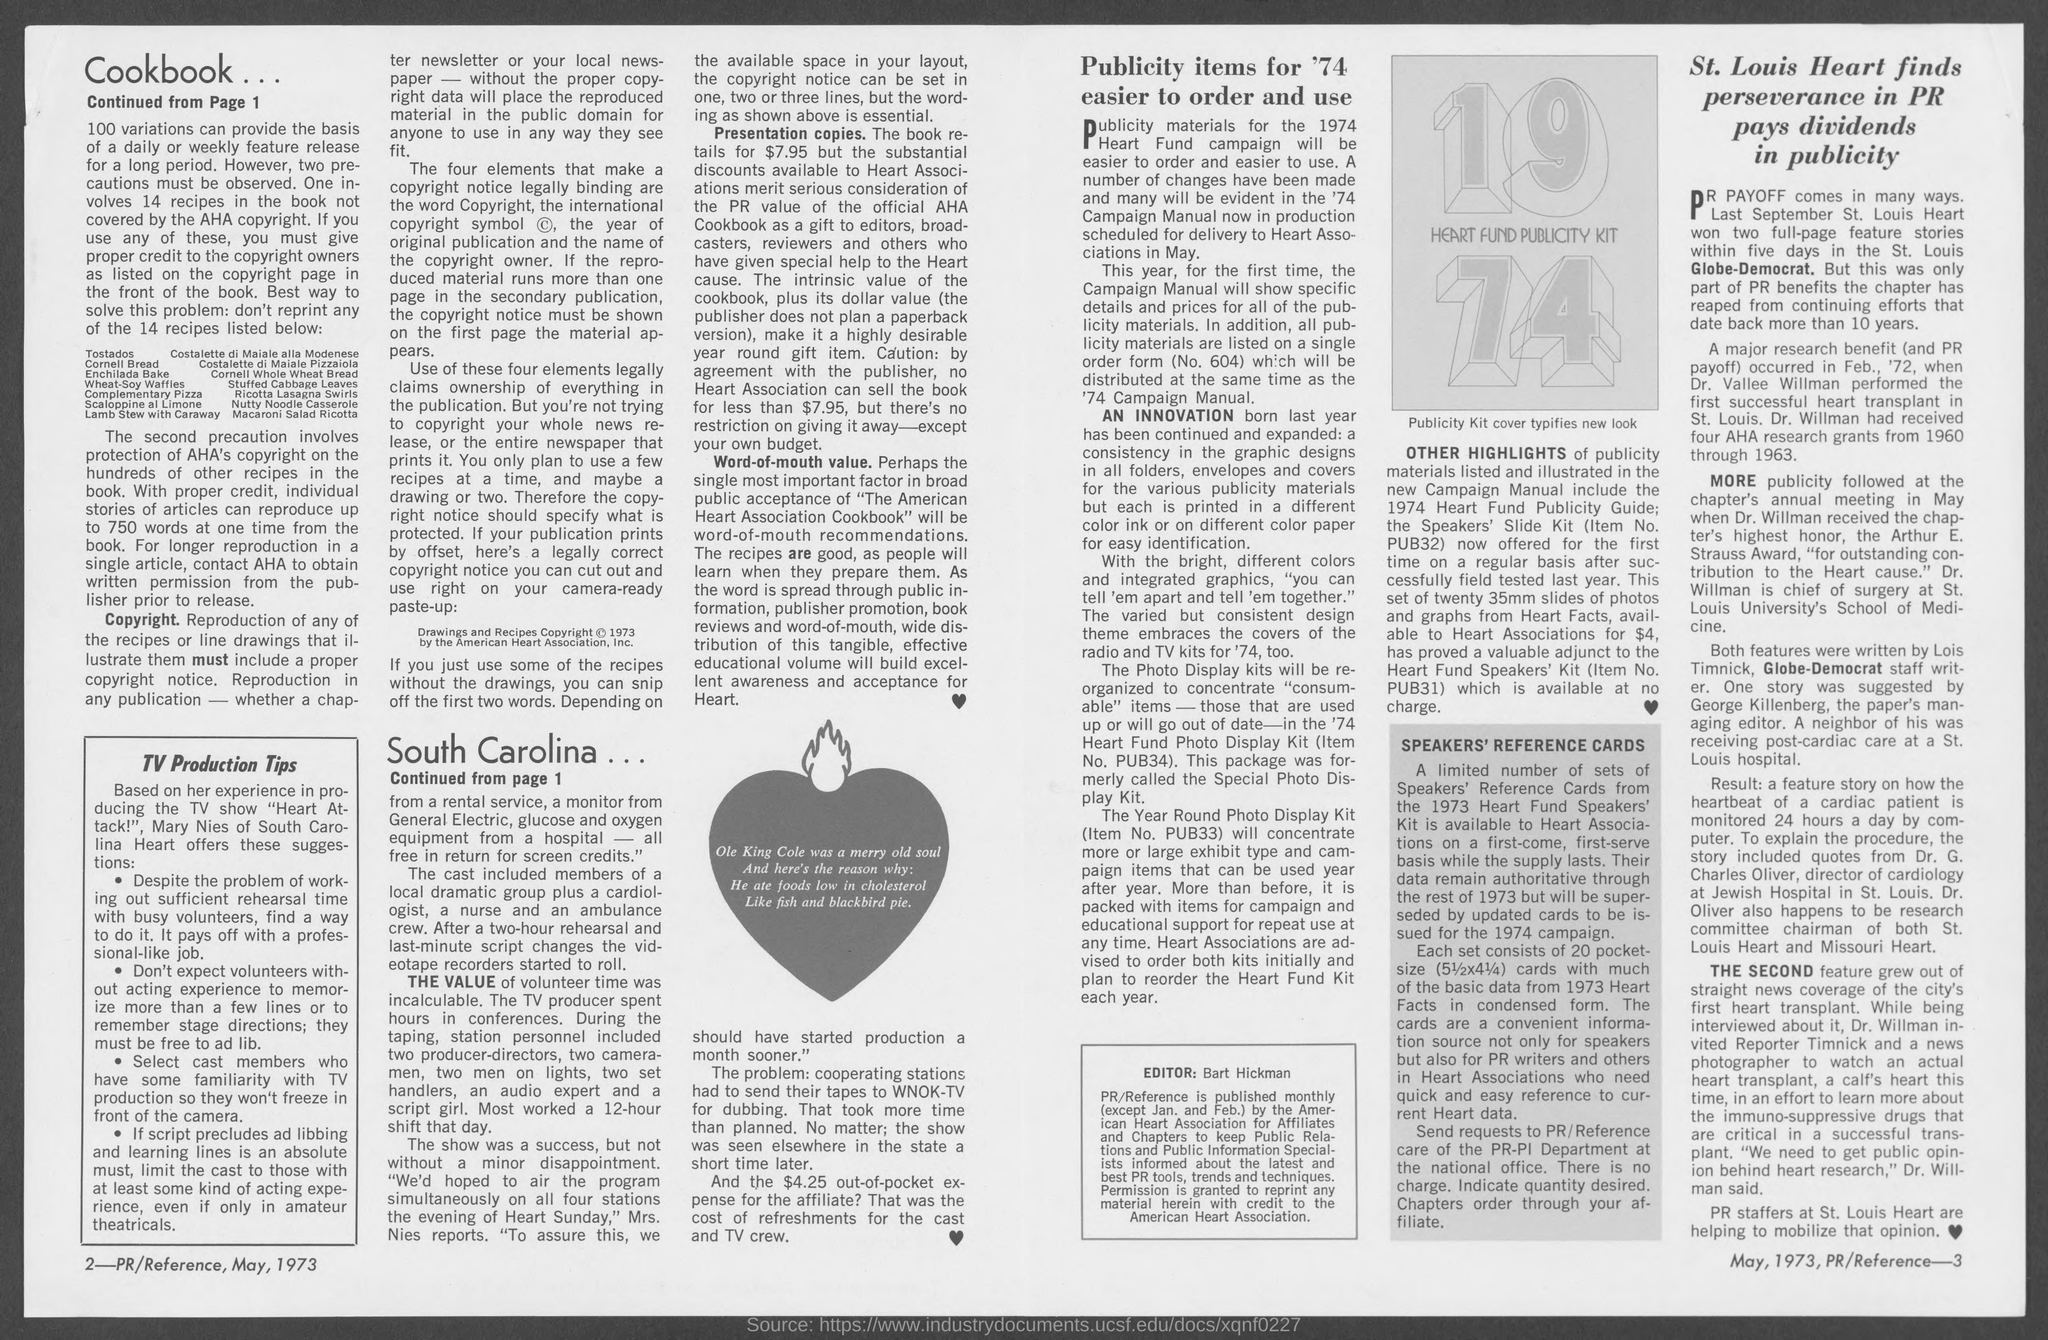The book retails for how much?
Provide a short and direct response. $7.95. What is the Date of publication?
Offer a terse response. May, 1973. 